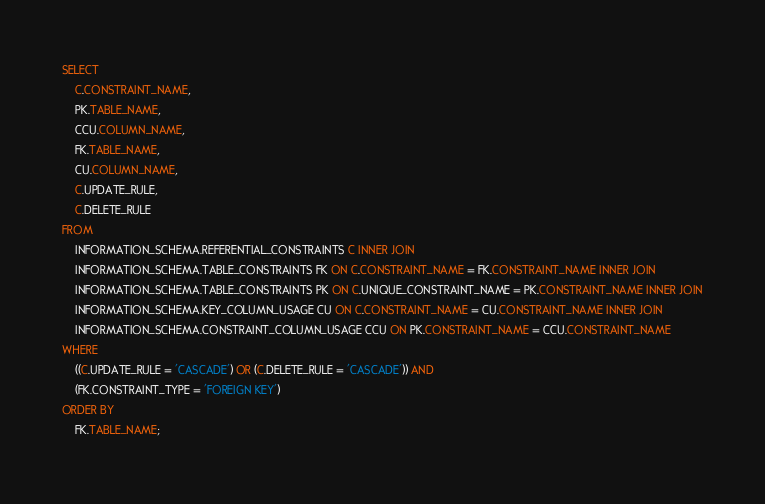<code> <loc_0><loc_0><loc_500><loc_500><_SQL_>SELECT
    C.CONSTRAINT_NAME,
    PK.TABLE_NAME,
    CCU.COLUMN_NAME,
    FK.TABLE_NAME,
    CU.COLUMN_NAME,
    C.UPDATE_RULE,
    C.DELETE_RULE
FROM
    INFORMATION_SCHEMA.REFERENTIAL_CONSTRAINTS C INNER JOIN
    INFORMATION_SCHEMA.TABLE_CONSTRAINTS FK ON C.CONSTRAINT_NAME = FK.CONSTRAINT_NAME INNER JOIN
    INFORMATION_SCHEMA.TABLE_CONSTRAINTS PK ON C.UNIQUE_CONSTRAINT_NAME = PK.CONSTRAINT_NAME INNER JOIN
    INFORMATION_SCHEMA.KEY_COLUMN_USAGE CU ON C.CONSTRAINT_NAME = CU.CONSTRAINT_NAME INNER JOIN
    INFORMATION_SCHEMA.CONSTRAINT_COLUMN_USAGE CCU ON PK.CONSTRAINT_NAME = CCU.CONSTRAINT_NAME
WHERE
    ((C.UPDATE_RULE = 'CASCADE') OR (C.DELETE_RULE = 'CASCADE')) AND
    (FK.CONSTRAINT_TYPE = 'FOREIGN KEY')
ORDER BY
    FK.TABLE_NAME;</code> 